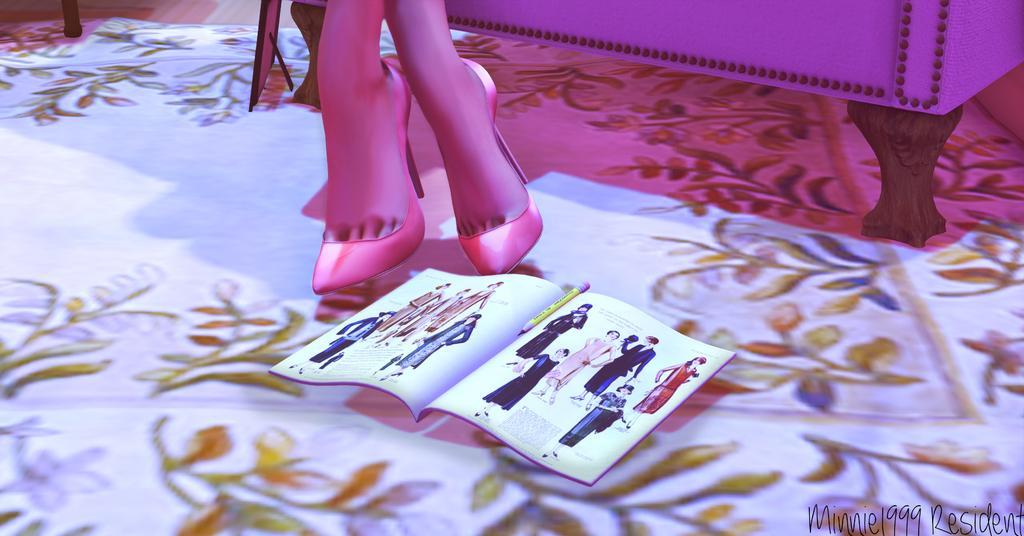In one or two sentences, can you explain what this image depicts? In this picture we can see an animated image, in which we can see some a woman legs, we can see a magazine with pencil are placed on the floor. 